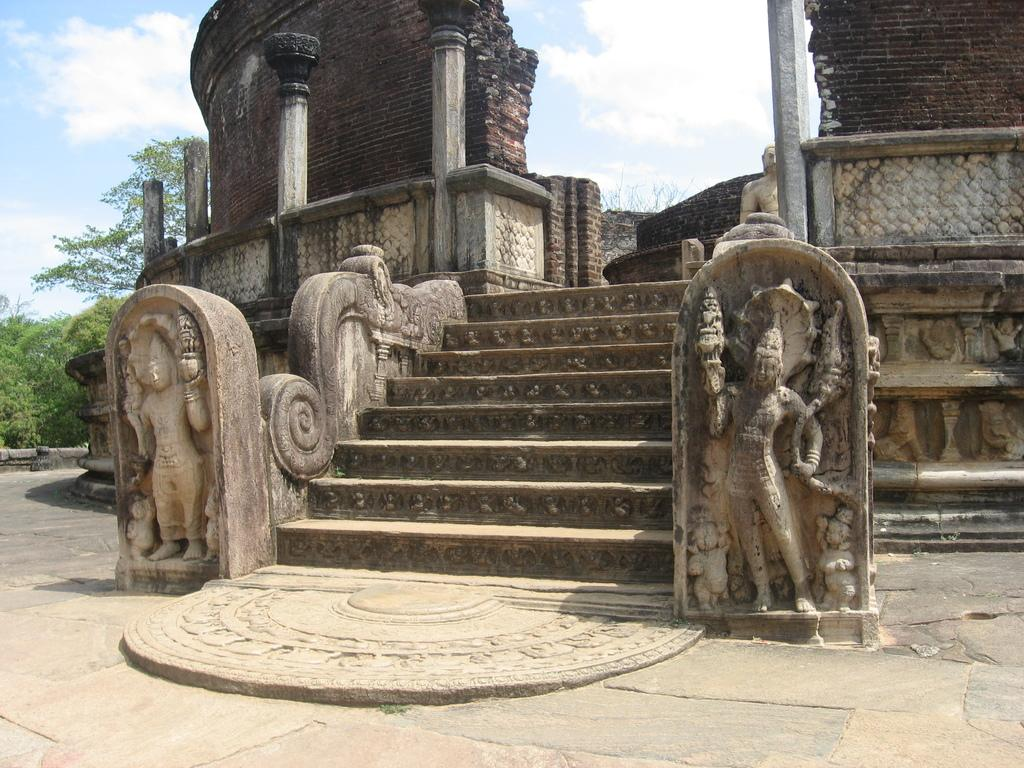What can be seen engraved on the rocks in the middle of the image? There are stars and sculptures engraved on rocks in the middle of the image. What architectural features are visible in the background of the image? There are pillars in the background of the image. What is visible in the sky in the background of the image? The sky with clouds is visible in the background of the image. What type of vegetation is present in the background of the image? Trees are present in the background of the image. How many sons are sitting on the chairs in the image? There are no sons or chairs present in the image. What emotion can be seen on the faces of the people in the image? There are no people present in the image, so it is not possible to determine their emotions. 